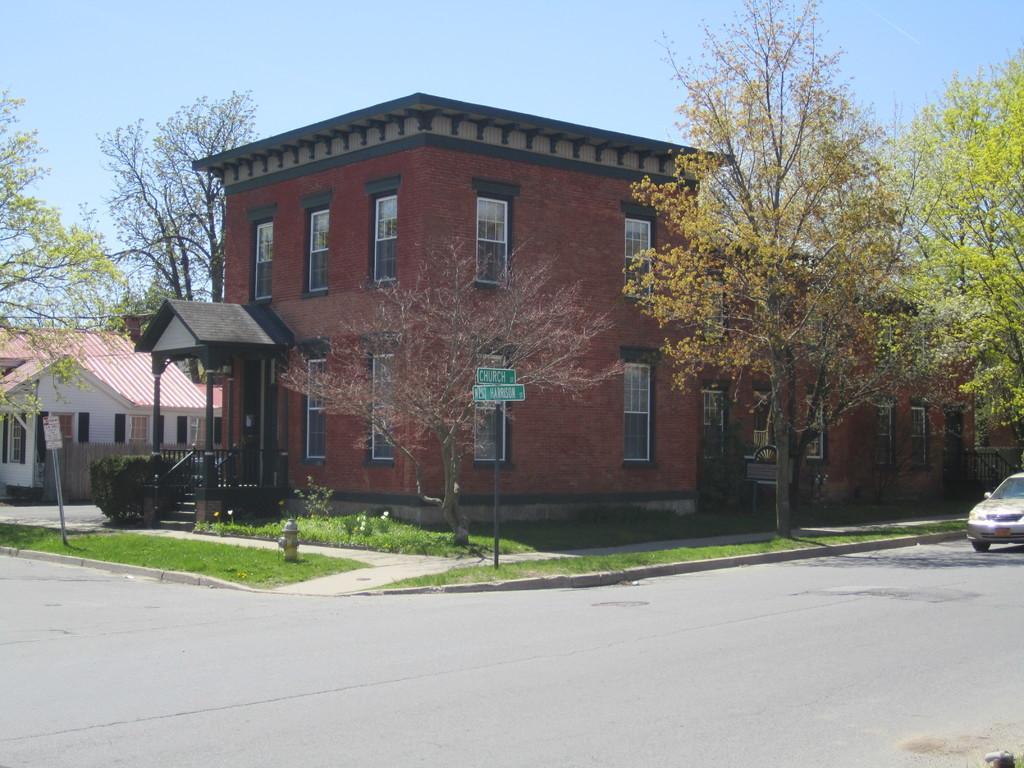Can you describe this image briefly? In this image we can see buildings, sign boards, staircase, railings, hydrant, trees and sky. 